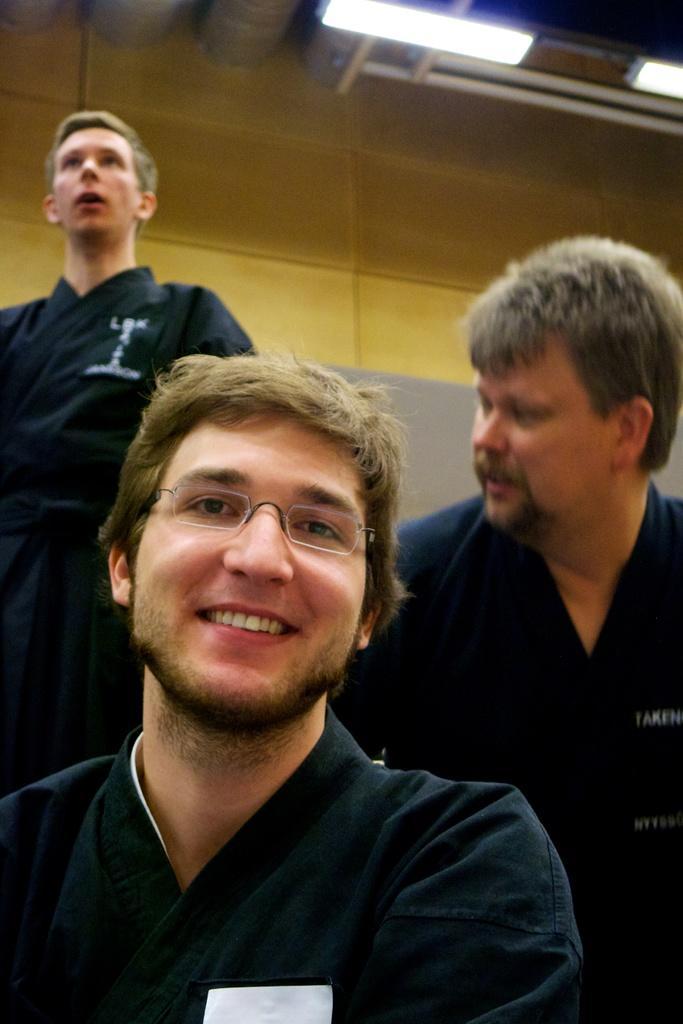In one or two sentences, can you explain what this image depicts? In this image we can see a man wearing the glasses and smiling. In the background we can see two persons. We can also see the wall and also the lights attached to the ceiling. 